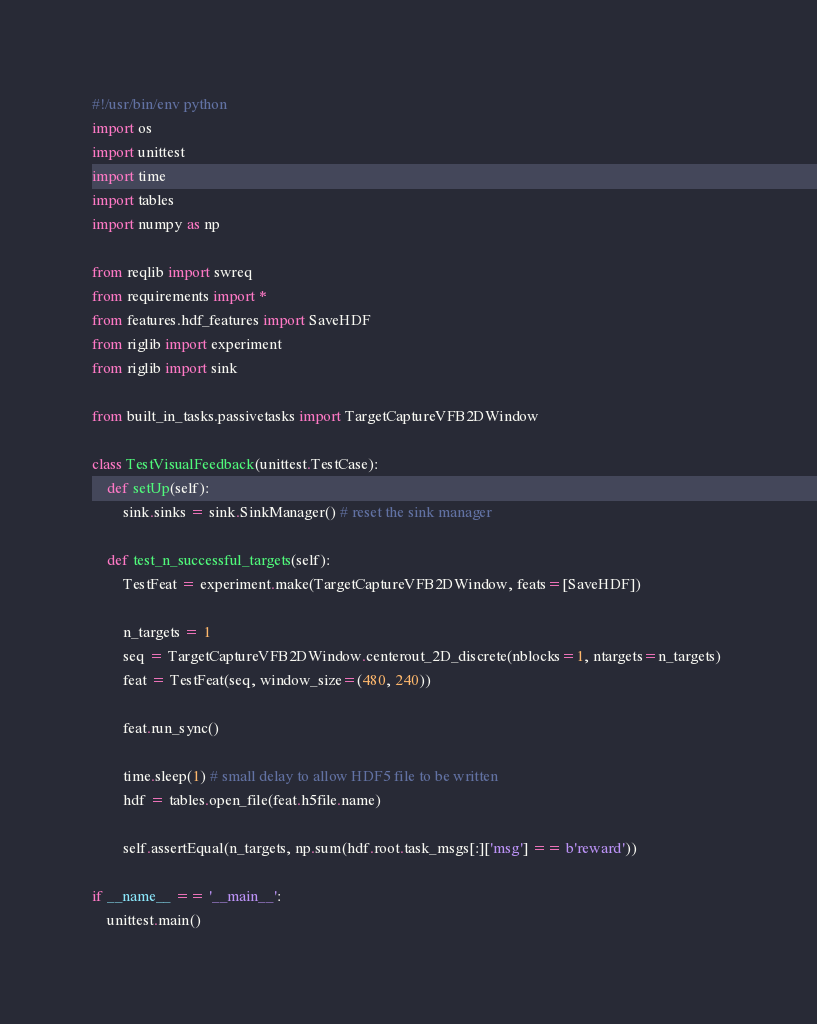<code> <loc_0><loc_0><loc_500><loc_500><_Python_>#!/usr/bin/env python
import os
import unittest
import time
import tables
import numpy as np

from reqlib import swreq
from requirements import *
from features.hdf_features import SaveHDF
from riglib import experiment
from riglib import sink

from built_in_tasks.passivetasks import TargetCaptureVFB2DWindow

class TestVisualFeedback(unittest.TestCase):
    def setUp(self):
        sink.sinks = sink.SinkManager() # reset the sink manager

    def test_n_successful_targets(self):
        TestFeat = experiment.make(TargetCaptureVFB2DWindow, feats=[SaveHDF])

        n_targets = 1
        seq = TargetCaptureVFB2DWindow.centerout_2D_discrete(nblocks=1, ntargets=n_targets) 
        feat = TestFeat(seq, window_size=(480, 240))

        feat.run_sync()

        time.sleep(1) # small delay to allow HDF5 file to be written
        hdf = tables.open_file(feat.h5file.name)

        self.assertEqual(n_targets, np.sum(hdf.root.task_msgs[:]['msg'] == b'reward'))

if __name__ == '__main__':
    unittest.main()
</code> 